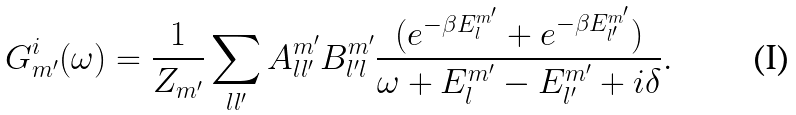Convert formula to latex. <formula><loc_0><loc_0><loc_500><loc_500>G _ { m ^ { \prime } } ^ { i } ( \omega ) = \frac { 1 } { { Z } _ { m ^ { \prime } } } \sum _ { l l ^ { \prime } } A ^ { m ^ { \prime } } _ { l l ^ { \prime } } B ^ { m ^ { \prime } } _ { l ^ { \prime } l } \frac { ( e ^ { - \beta E ^ { m ^ { \prime } } _ { l } } + e ^ { - \beta E ^ { m ^ { \prime } } _ { l ^ { \prime } } } ) } { \omega + E ^ { m ^ { \prime } } _ { l } - E ^ { m ^ { \prime } } _ { l ^ { \prime } } + i \delta } .</formula> 